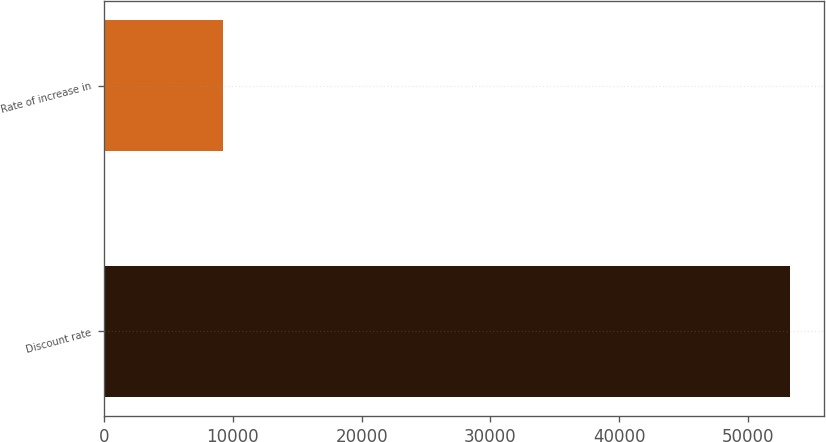Convert chart. <chart><loc_0><loc_0><loc_500><loc_500><bar_chart><fcel>Discount rate<fcel>Rate of increase in<nl><fcel>53261<fcel>9232<nl></chart> 